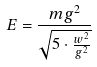Convert formula to latex. <formula><loc_0><loc_0><loc_500><loc_500>E = \frac { m g ^ { 2 } } { \sqrt { 5 \cdot \frac { w ^ { 2 } } { g ^ { 2 } } } }</formula> 